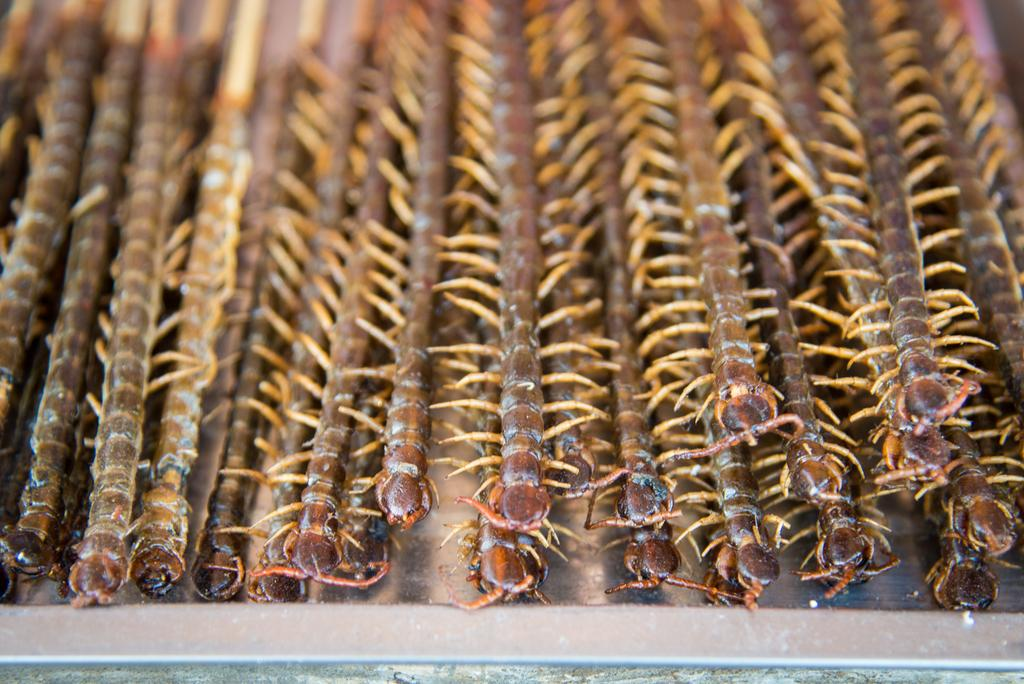What type of creatures can be seen in the image? There are insects in the image. Where are the insects located? The insects are on a surface. What type of humor can be found in the image? There is no humor present in the image, as it features insects on a surface. 